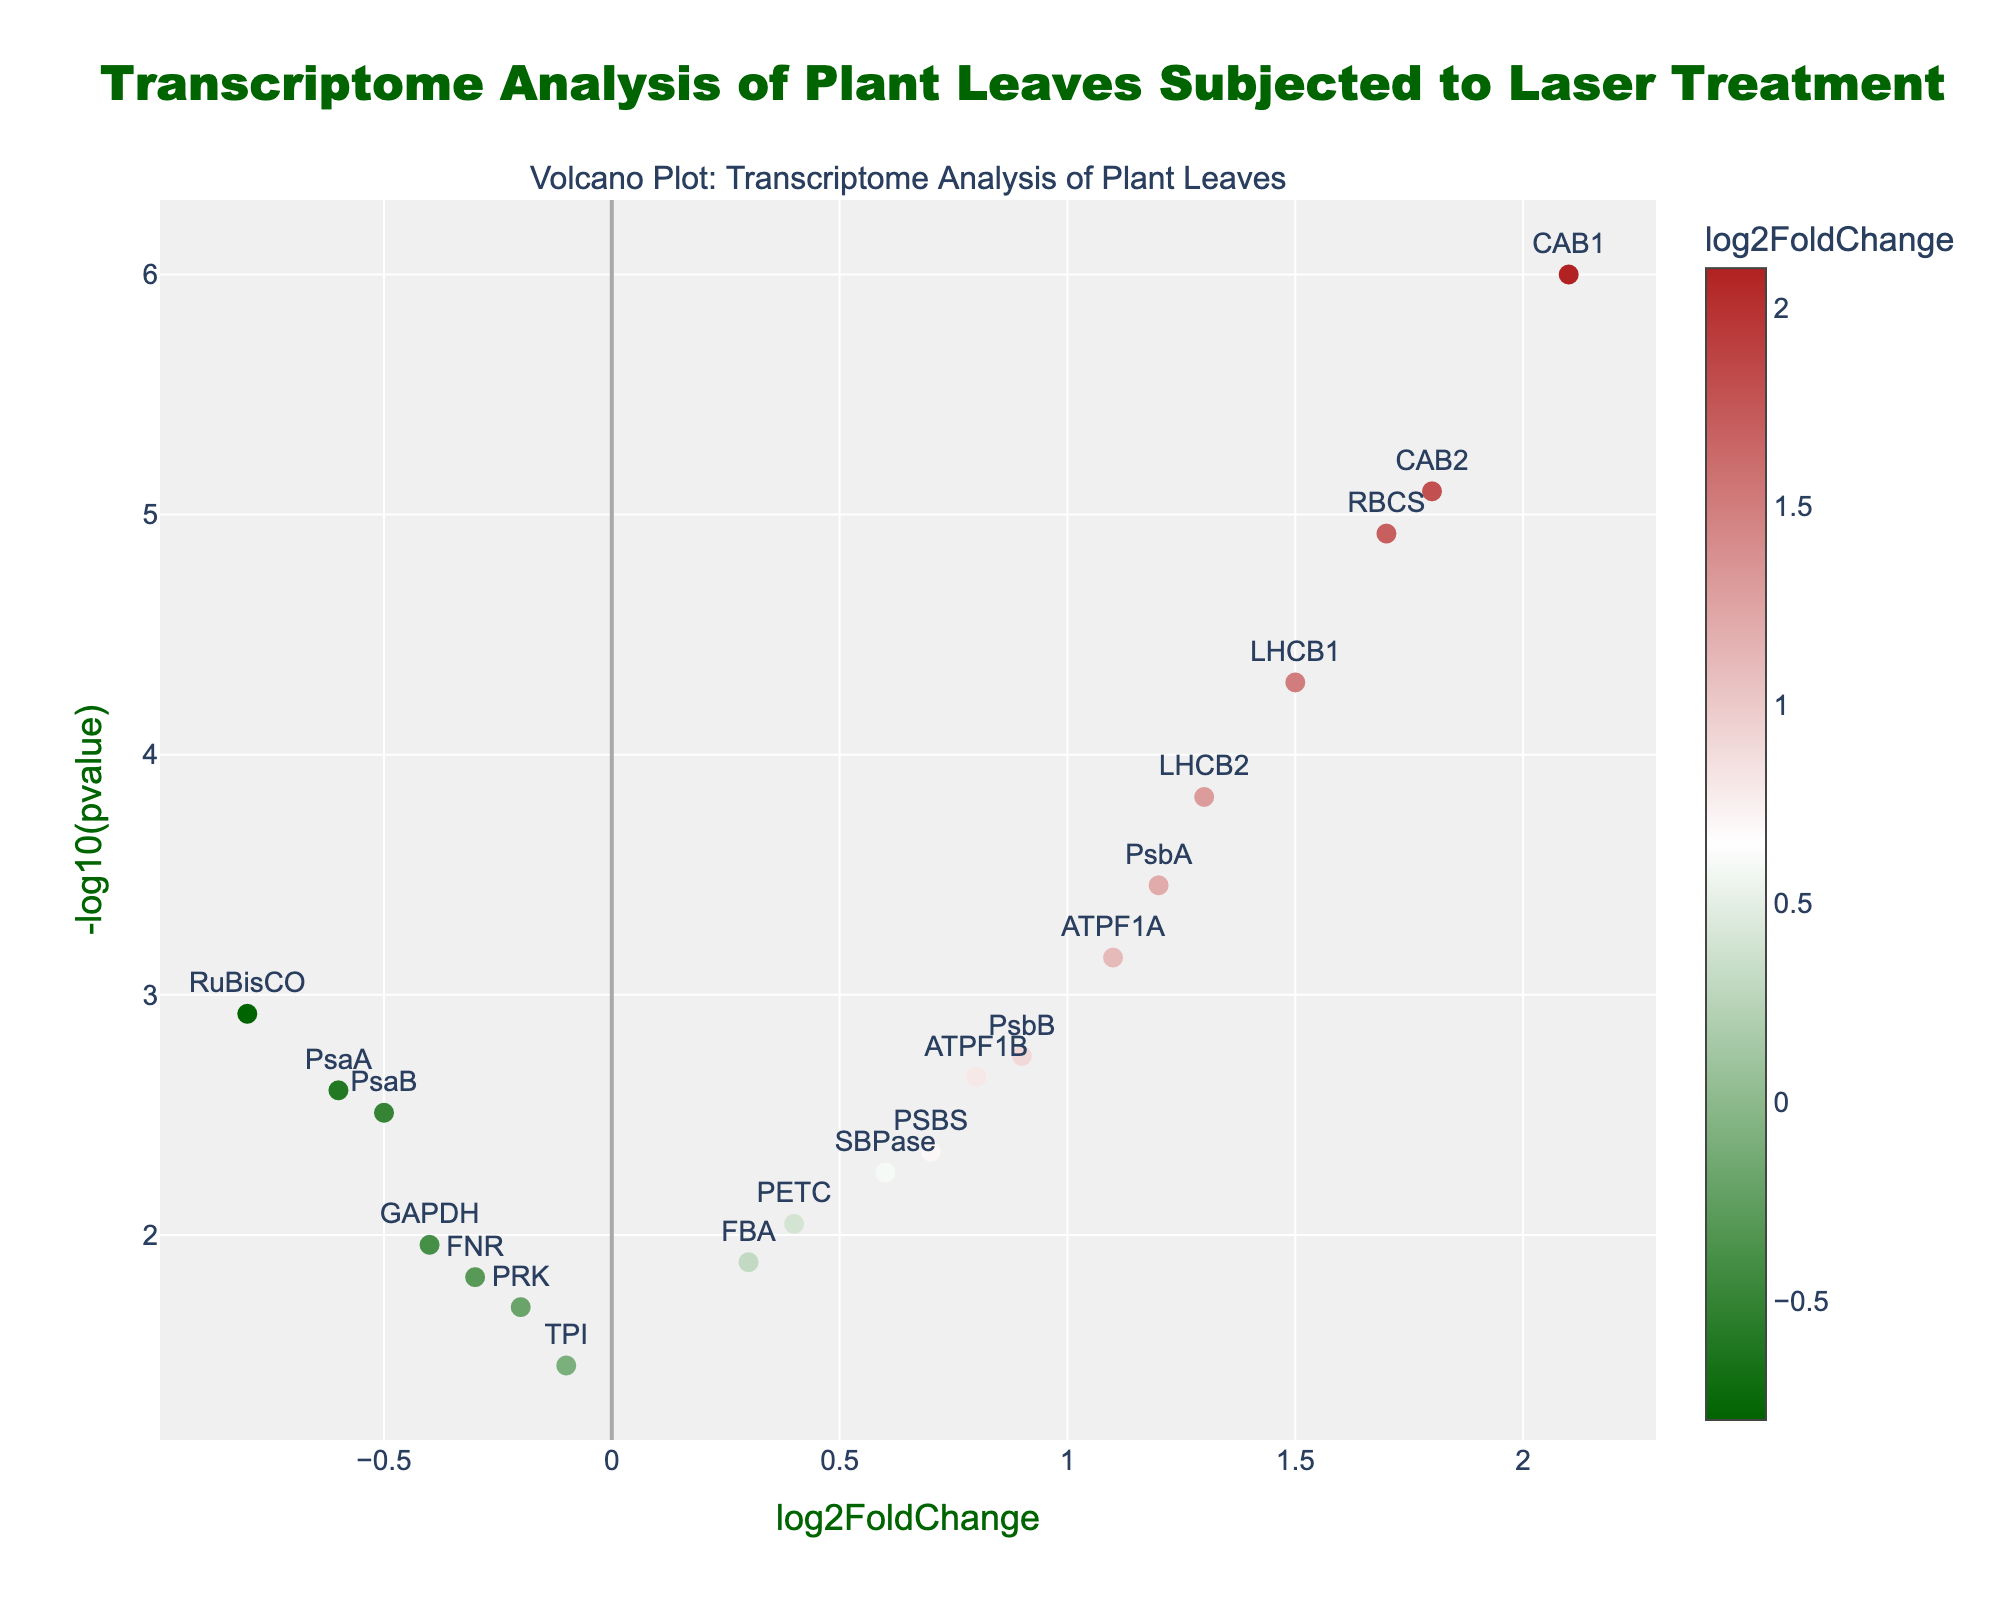What's the title of the plot? The title is typically displayed prominently at the top of the plot. In this case, it reads "Transcriptome Analysis of Plant Leaves Subjected to Laser Treatment."
Answer: Transcriptome Analysis of Plant Leaves Subjected to Laser Treatment What is represented on the x-axis and y-axis? The x-axis represents 'log2FoldChange,' indicating the fold change in gene expression levels. The y-axis represents '-log10(pvalue),' indicating the statistical significance of the change.
Answer: log2FoldChange and -log10(pvalue) Which gene has the highest log2FoldChange value? By examining the x-axis values, CAB1 has the highest log2FoldChange value. It appears farthest to the right.
Answer: CAB1 Which gene shows the lowest p-value? The lowest p-value corresponds to the highest '-log10(pvalue)' value. CAB1, positioned highest on the y-axis, has the lowest p-value.
Answer: CAB1 How many genes have a log2FoldChange greater than 1? Count the points to the right of the 1 on the x-axis. Genes LHCB1, LHCB2, CAB1, CAB2, RBCS, and PsbA are all included, totaling 6.
Answer: 6 Which gene has a log2FoldChange of less than -0.5? Locate the points left of -0.5 on the x-axis. RuBisCO and PsaA fit this criterion.
Answer: RuBisCO and PsaA What's the range of p-values represented in the plot? Translate the highest and lowest '-log10(pvalue)' back to p-value scale. Highest around 6.0 (10^-6) for CAB1 and lowest around 1.5 (10^-1.5) for TPI.
Answer: 10^-6 to 10^-1.5 Is there a gene with a log2FoldChange close to zero? Examine points near the x=0 line. FNR and PRK have log2FoldChange values of -0.3 and -0.2, respectively, indicating they are close to zero.
Answer: FNR and PRK How many genes have p-values less than 0.01? Convert 0.01 to -log10, which is about 2. Points above y=2 line meet this threshold. LHCB1, LHCB2, CAB1, CAB2, RBCS, PsbA, RuBisCO, PsbB, PETC, and ATPF1A fit this criterion, totaling 10.
Answer: 10 